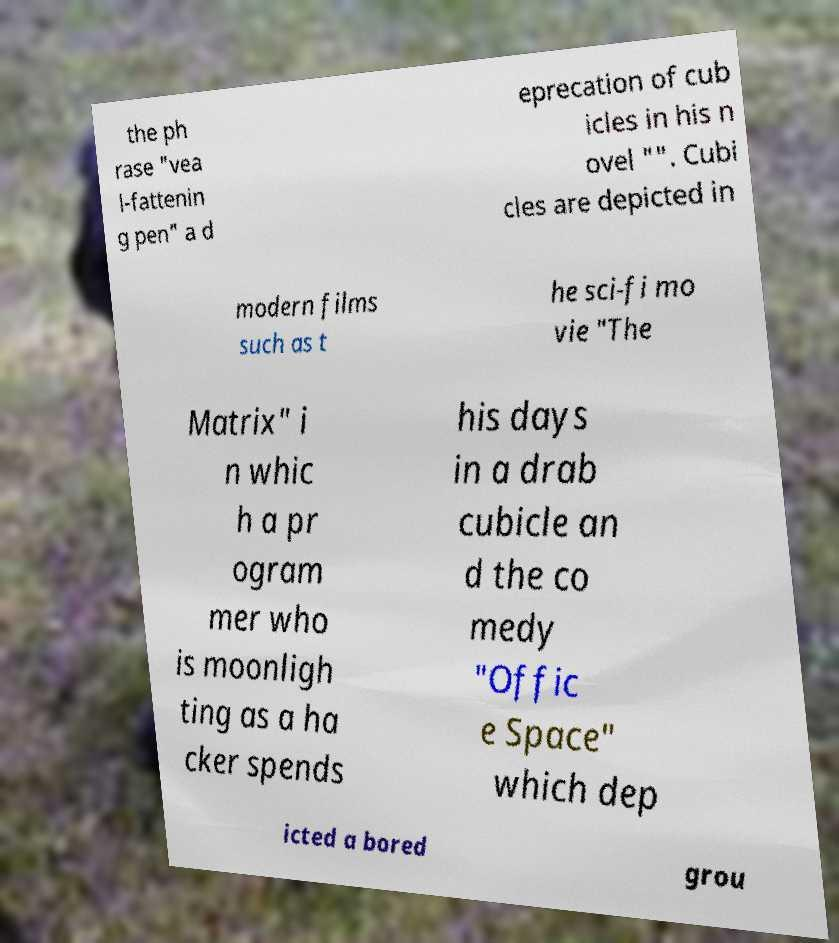Could you assist in decoding the text presented in this image and type it out clearly? the ph rase "vea l-fattenin g pen" a d eprecation of cub icles in his n ovel "". Cubi cles are depicted in modern films such as t he sci-fi mo vie "The Matrix" i n whic h a pr ogram mer who is moonligh ting as a ha cker spends his days in a drab cubicle an d the co medy "Offic e Space" which dep icted a bored grou 